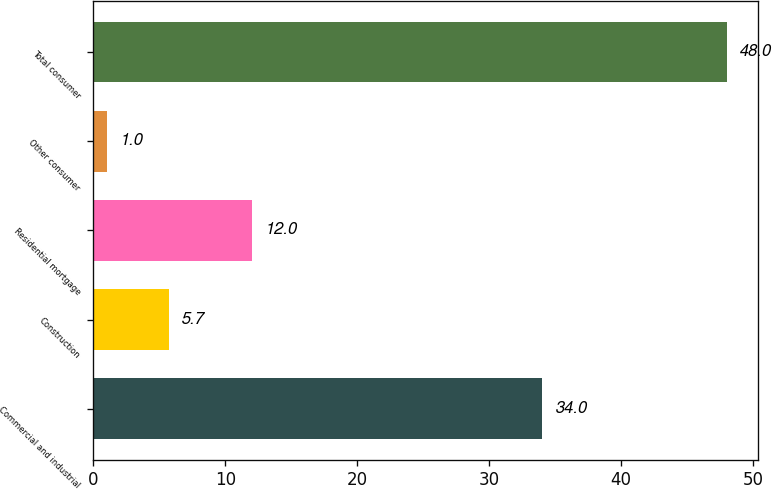Convert chart. <chart><loc_0><loc_0><loc_500><loc_500><bar_chart><fcel>Commercial and industrial<fcel>Construction<fcel>Residential mortgage<fcel>Other consumer<fcel>Total consumer<nl><fcel>34<fcel>5.7<fcel>12<fcel>1<fcel>48<nl></chart> 